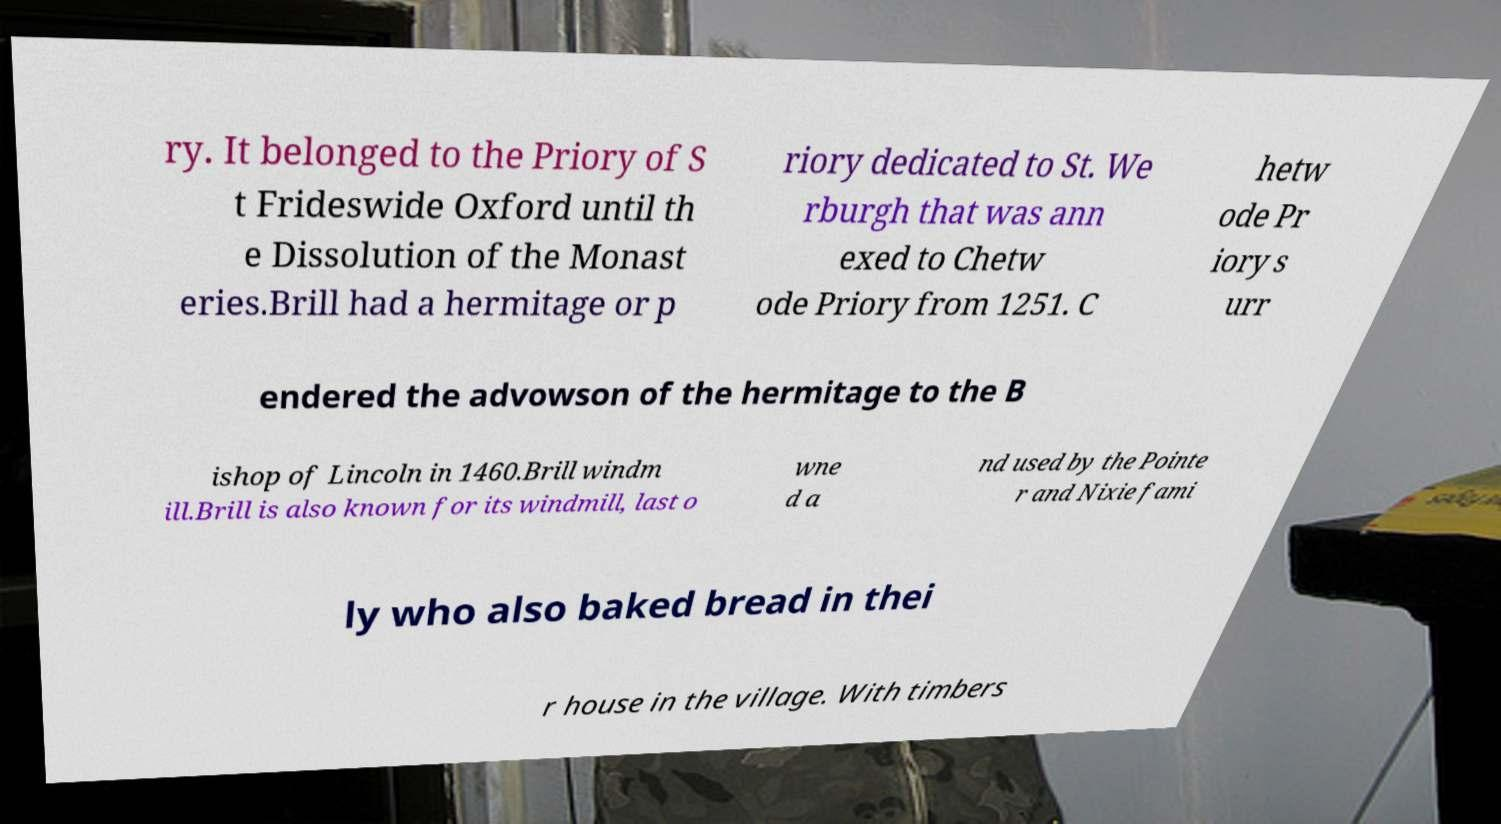Could you assist in decoding the text presented in this image and type it out clearly? ry. It belonged to the Priory of S t Frideswide Oxford until th e Dissolution of the Monast eries.Brill had a hermitage or p riory dedicated to St. We rburgh that was ann exed to Chetw ode Priory from 1251. C hetw ode Pr iory s urr endered the advowson of the hermitage to the B ishop of Lincoln in 1460.Brill windm ill.Brill is also known for its windmill, last o wne d a nd used by the Pointe r and Nixie fami ly who also baked bread in thei r house in the village. With timbers 